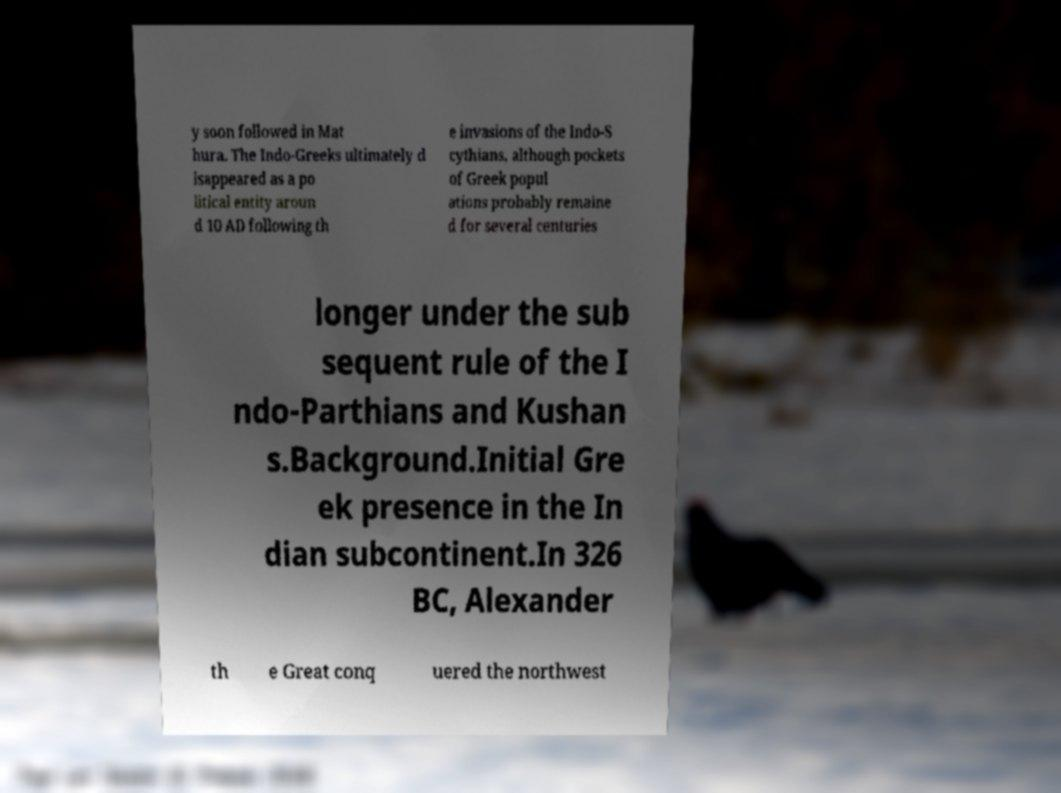Can you read and provide the text displayed in the image?This photo seems to have some interesting text. Can you extract and type it out for me? y soon followed in Mat hura. The Indo-Greeks ultimately d isappeared as a po litical entity aroun d 10 AD following th e invasions of the Indo-S cythians, although pockets of Greek popul ations probably remaine d for several centuries longer under the sub sequent rule of the I ndo-Parthians and Kushan s.Background.Initial Gre ek presence in the In dian subcontinent.In 326 BC, Alexander th e Great conq uered the northwest 